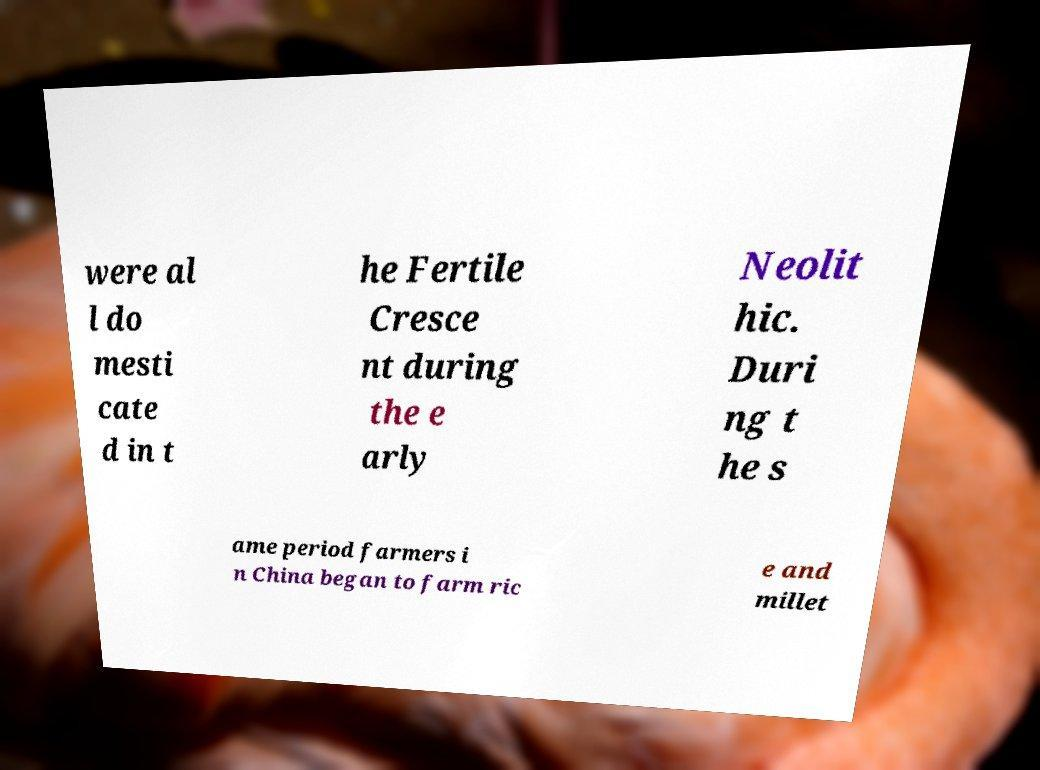What messages or text are displayed in this image? I need them in a readable, typed format. were al l do mesti cate d in t he Fertile Cresce nt during the e arly Neolit hic. Duri ng t he s ame period farmers i n China began to farm ric e and millet 